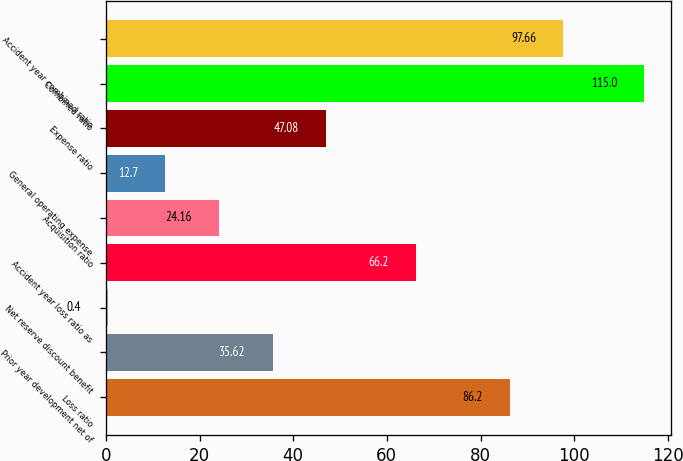<chart> <loc_0><loc_0><loc_500><loc_500><bar_chart><fcel>Loss ratio<fcel>Prior year development net of<fcel>Net reserve discount benefit<fcel>Accident year loss ratio as<fcel>Acquisition ratio<fcel>General operating expense<fcel>Expense ratio<fcel>Combined ratio<fcel>Accident year combined ratio<nl><fcel>86.2<fcel>35.62<fcel>0.4<fcel>66.2<fcel>24.16<fcel>12.7<fcel>47.08<fcel>115<fcel>97.66<nl></chart> 